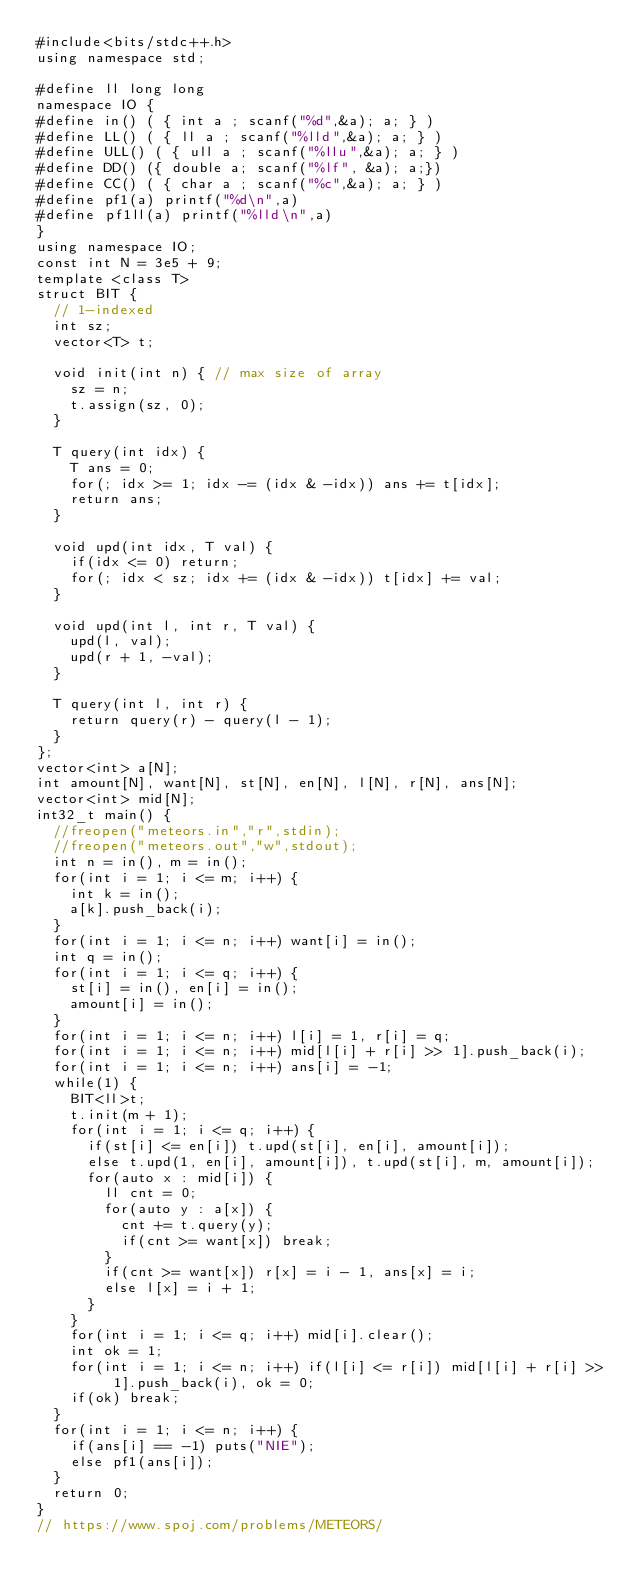Convert code to text. <code><loc_0><loc_0><loc_500><loc_500><_C++_>#include<bits/stdc++.h>
using namespace std;

#define ll long long
namespace IO {
#define in() ( { int a ; scanf("%d",&a); a; } )
#define LL() ( { ll a ; scanf("%lld",&a); a; } )
#define ULL() ( { ull a ; scanf("%llu",&a); a; } )
#define DD() ({ double a; scanf("%lf", &a); a;})
#define CC() ( { char a ; scanf("%c",&a); a; } )
#define pf1(a) printf("%d\n",a)
#define pf1ll(a) printf("%lld\n",a)
}
using namespace IO;
const int N = 3e5 + 9;
template <class T>
struct BIT {
  // 1-indexed
  int sz;
  vector<T> t;

  void init(int n) { // max size of array
    sz = n;
    t.assign(sz, 0);
  }

  T query(int idx) {
    T ans = 0;
    for(; idx >= 1; idx -= (idx & -idx)) ans += t[idx];
    return ans;
  }

  void upd(int idx, T val) {
    if(idx <= 0) return;
    for(; idx < sz; idx += (idx & -idx)) t[idx] += val;
  }

  void upd(int l, int r, T val) {
    upd(l, val);
    upd(r + 1, -val);
  }

  T query(int l, int r) {
    return query(r) - query(l - 1);
  }
};
vector<int> a[N];
int amount[N], want[N], st[N], en[N], l[N], r[N], ans[N];
vector<int> mid[N];
int32_t main() {
  //freopen("meteors.in","r",stdin);
  //freopen("meteors.out","w",stdout);
  int n = in(), m = in();
  for(int i = 1; i <= m; i++) {
    int k = in();
    a[k].push_back(i);
  }
  for(int i = 1; i <= n; i++) want[i] = in();
  int q = in();
  for(int i = 1; i <= q; i++) {
    st[i] = in(), en[i] = in();
    amount[i] = in();
  }
  for(int i = 1; i <= n; i++) l[i] = 1, r[i] = q;
  for(int i = 1; i <= n; i++) mid[l[i] + r[i] >> 1].push_back(i);
  for(int i = 1; i <= n; i++) ans[i] = -1;
  while(1) {
    BIT<ll>t;
    t.init(m + 1);
    for(int i = 1; i <= q; i++) {
      if(st[i] <= en[i]) t.upd(st[i], en[i], amount[i]);
      else t.upd(1, en[i], amount[i]), t.upd(st[i], m, amount[i]);
      for(auto x : mid[i]) {
        ll cnt = 0;
        for(auto y : a[x]) {
          cnt += t.query(y);
          if(cnt >= want[x]) break;
        }
        if(cnt >= want[x]) r[x] = i - 1, ans[x] = i;
        else l[x] = i + 1;
      }
    }
    for(int i = 1; i <= q; i++) mid[i].clear();
    int ok = 1;
    for(int i = 1; i <= n; i++) if(l[i] <= r[i]) mid[l[i] + r[i] >> 1].push_back(i), ok = 0;
    if(ok) break;
  }
  for(int i = 1; i <= n; i++) {
    if(ans[i] == -1) puts("NIE");
    else pf1(ans[i]);
  }
  return 0;
}
// https://www.spoj.com/problems/METEORS/
</code> 